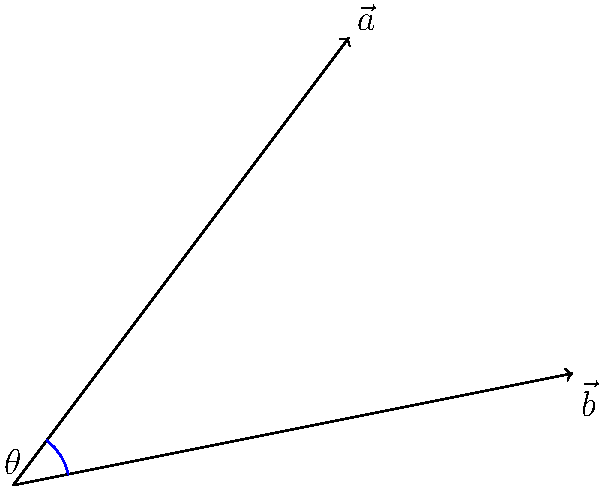In a stakeholder analysis for a new PR campaign, two key interest groups are represented by vectors $\vec{a} = (3, 4)$ and $\vec{b} = (5, 1)$. Calculate the angle between these vectors to determine how closely aligned these stakeholders' interests are. Round your answer to the nearest degree. To find the angle between two vectors, we can use the dot product formula:

$$\cos \theta = \frac{\vec{a} \cdot \vec{b}}{|\vec{a}| |\vec{b}|}$$

Step 1: Calculate the dot product $\vec{a} \cdot \vec{b}$
$$\vec{a} \cdot \vec{b} = (3 \times 5) + (4 \times 1) = 15 + 4 = 19$$

Step 2: Calculate the magnitudes of $\vec{a}$ and $\vec{b}$
$$|\vec{a}| = \sqrt{3^2 + 4^2} = \sqrt{9 + 16} = \sqrt{25} = 5$$
$$|\vec{b}| = \sqrt{5^2 + 1^2} = \sqrt{25 + 1} = \sqrt{26}$$

Step 3: Apply the dot product formula
$$\cos \theta = \frac{19}{5 \sqrt{26}}$$

Step 4: Take the inverse cosine (arccos) of both sides
$$\theta = \arccos(\frac{19}{5 \sqrt{26}})$$

Step 5: Calculate and round to the nearest degree
$$\theta \approx 44.42° \approx 44°$$

This angle represents the degree of alignment between the two stakeholder groups' interests. A smaller angle would indicate more closely aligned interests.
Answer: 44° 